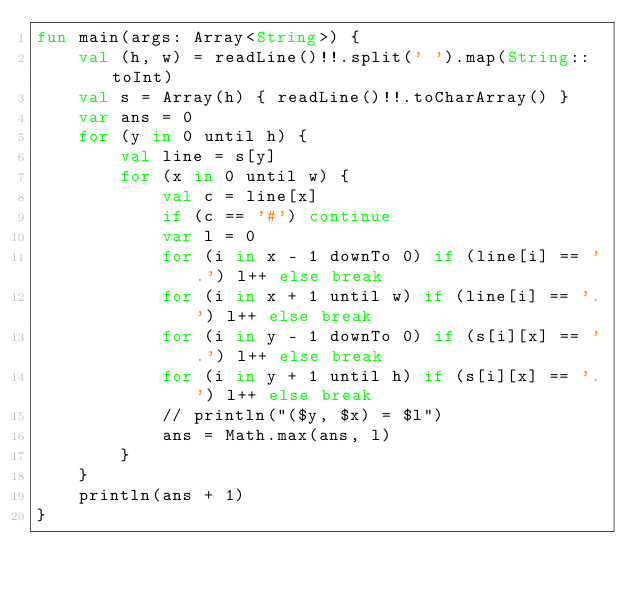<code> <loc_0><loc_0><loc_500><loc_500><_Kotlin_>fun main(args: Array<String>) {
    val (h, w) = readLine()!!.split(' ').map(String::toInt)
    val s = Array(h) { readLine()!!.toCharArray() }
    var ans = 0
    for (y in 0 until h) {
        val line = s[y]
        for (x in 0 until w) {
            val c = line[x]
            if (c == '#') continue
            var l = 0
            for (i in x - 1 downTo 0) if (line[i] == '.') l++ else break
            for (i in x + 1 until w) if (line[i] == '.') l++ else break
            for (i in y - 1 downTo 0) if (s[i][x] == '.') l++ else break
            for (i in y + 1 until h) if (s[i][x] == '.') l++ else break
            // println("($y, $x) = $l")
            ans = Math.max(ans, l)
        }
    }
    println(ans + 1)
}
</code> 